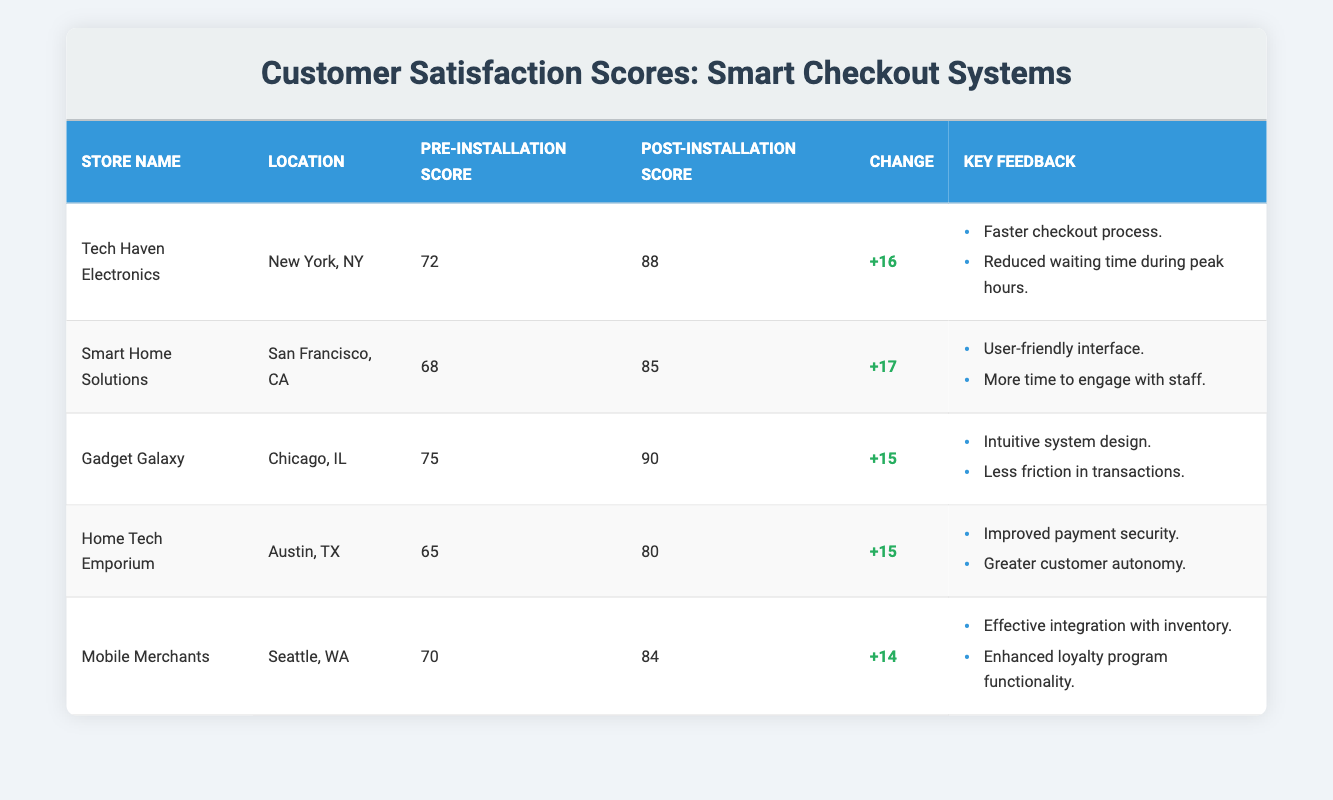What is the highest post-installation score recorded? To find the highest post-installation score, I look through the Post-Installation Score column. The scores listed are 88, 85, 90, 80, and 84. The maximum score is 90.
Answer: 90 Which store had the lowest pre-installation score? The pre-installation scores are 72, 68, 75, 65, and 70. The lowest score among these is 65, which belongs to Home Tech Emporium.
Answer: Home Tech Emporium What is the average change in customer satisfaction scores across all stores? I sum up all the changes: 16 + 17 + 15 + 15 + 14 = 77. There are 5 stores, so I divide the total change by 5: 77 / 5 = 15.4.
Answer: 15.4 Is the change in customer satisfaction score for Smart Home Solutions greater than that of Home Tech Emporium? The change for Smart Home Solutions is +17, while for Home Tech Emporium it is +15. Since 17 is greater than 15, the statement is true.
Answer: Yes Which store experienced the second-highest improvement in customer satisfaction scores? The changes in scores are +16 (Tech Haven Electronics), +17 (Smart Home Solutions), +15 (Gadget Galaxy), +15 (Home Tech Emporium), +14 (Mobile Merchants). The second-highest change is +16, recorded by Tech Haven Electronics.
Answer: Tech Haven Electronics In which location did the store with the highest post-installation score reside? The highest post-installation score is 90, which corresponds to Gadget Galaxy located in Chicago, IL.
Answer: Chicago, IL Does every store have a post-installation score greater than 80? The post-installation scores are 88, 85, 90, 80, and 84. Since one store (Home Tech Emporium) has a score of exactly 80, not every store exceeds 80.
Answer: No What is the difference in pre-installation scores between the highest and lowest? The highest pre-installation score is 75 (Gadget Galaxy) and the lowest is 65 (Home Tech Emporium). The difference is 75 - 65 = 10.
Answer: 10 What two key feedback points were shared by customers of Gadget Galaxy? The table lists two key feedback points for Gadget Galaxy: “Intuitive system design” and “Less friction in transactions.”
Answer: Intuitive system design and Less friction in transactions How many key feedback points did Mobile Merchants receive? Mobile Merchants has two points of key feedback: “Effective integration with inventory” and “Enhanced loyalty program functionality.” Thus, there are a total of two feedback points.
Answer: 2 